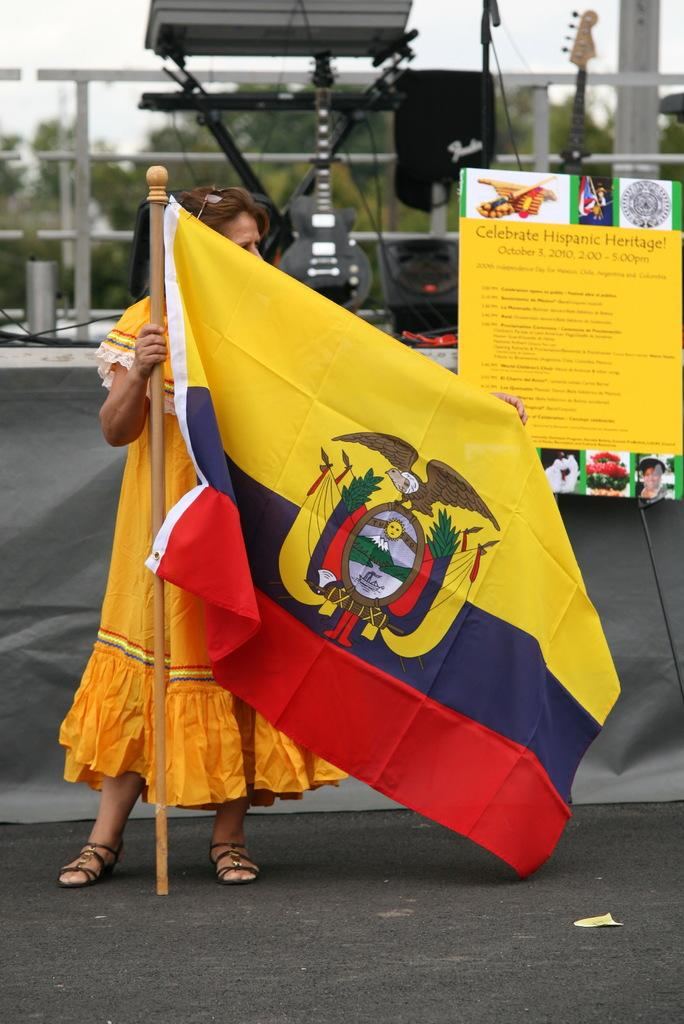What is the lady in the center of the image holding? The lady in the center of the image is holding a flag. What else can be seen in the center of the image? There is a board in the center of the image. What can be observed in the background of the image? Musical instruments are visible in the background. What type of lead is being used to play the musical instruments in the background? There is no lead visible in the image, and the musical instruments are not being played. 